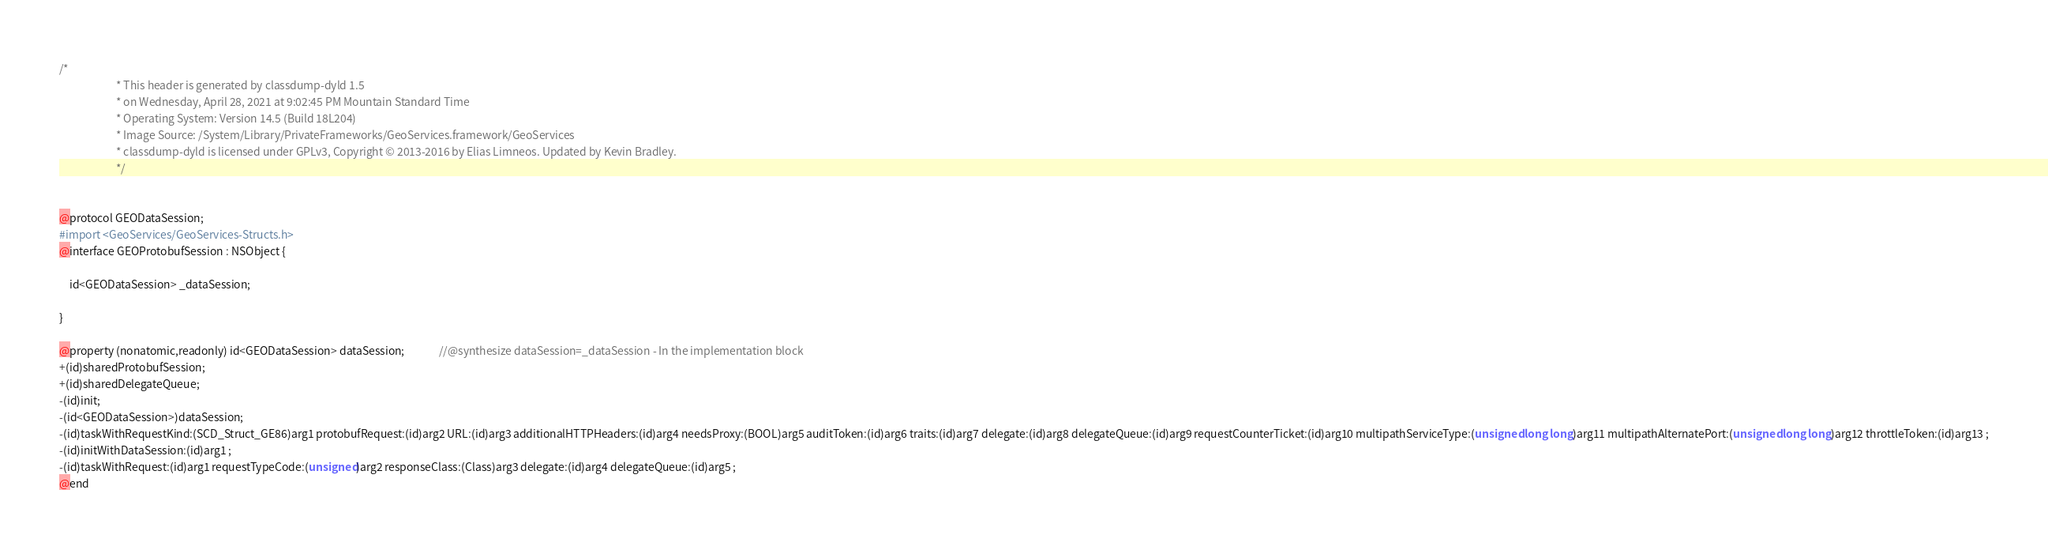<code> <loc_0><loc_0><loc_500><loc_500><_C_>/*
                       * This header is generated by classdump-dyld 1.5
                       * on Wednesday, April 28, 2021 at 9:02:45 PM Mountain Standard Time
                       * Operating System: Version 14.5 (Build 18L204)
                       * Image Source: /System/Library/PrivateFrameworks/GeoServices.framework/GeoServices
                       * classdump-dyld is licensed under GPLv3, Copyright © 2013-2016 by Elias Limneos. Updated by Kevin Bradley.
                       */


@protocol GEODataSession;
#import <GeoServices/GeoServices-Structs.h>
@interface GEOProtobufSession : NSObject {

	id<GEODataSession> _dataSession;

}

@property (nonatomic,readonly) id<GEODataSession> dataSession;              //@synthesize dataSession=_dataSession - In the implementation block
+(id)sharedProtobufSession;
+(id)sharedDelegateQueue;
-(id)init;
-(id<GEODataSession>)dataSession;
-(id)taskWithRequestKind:(SCD_Struct_GE86)arg1 protobufRequest:(id)arg2 URL:(id)arg3 additionalHTTPHeaders:(id)arg4 needsProxy:(BOOL)arg5 auditToken:(id)arg6 traits:(id)arg7 delegate:(id)arg8 delegateQueue:(id)arg9 requestCounterTicket:(id)arg10 multipathServiceType:(unsigned long long)arg11 multipathAlternatePort:(unsigned long long)arg12 throttleToken:(id)arg13 ;
-(id)initWithDataSession:(id)arg1 ;
-(id)taskWithRequest:(id)arg1 requestTypeCode:(unsigned)arg2 responseClass:(Class)arg3 delegate:(id)arg4 delegateQueue:(id)arg5 ;
@end

</code> 